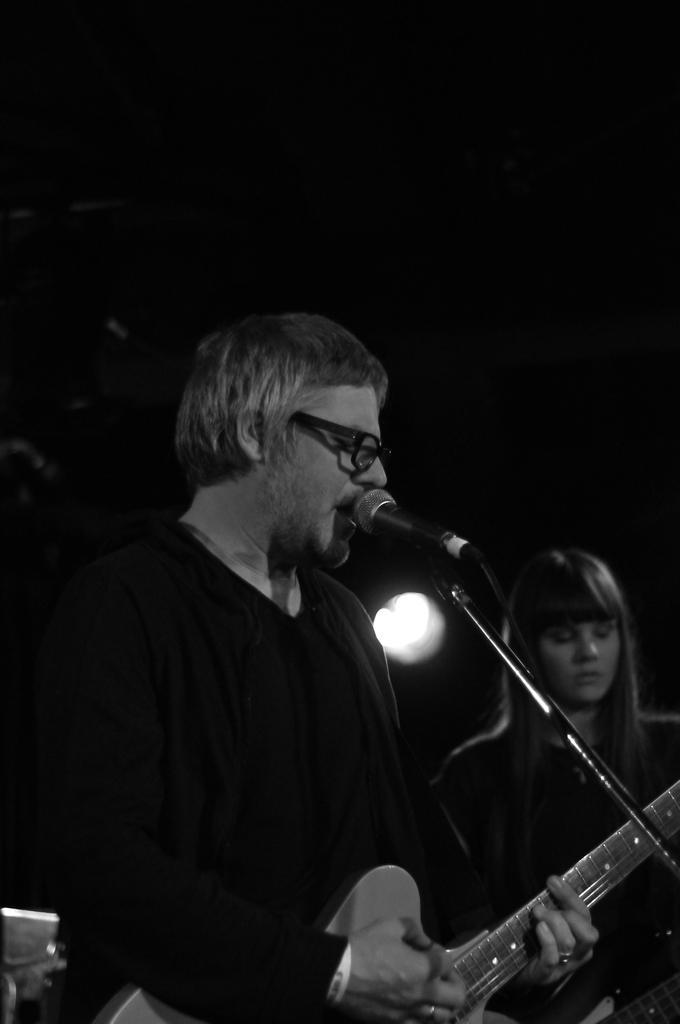Can you describe this image briefly? In the center of the image there is a man standing and playing a guitar. He is singing a song. There is a mic placed before him next to him there is a lady behind them there is light. 